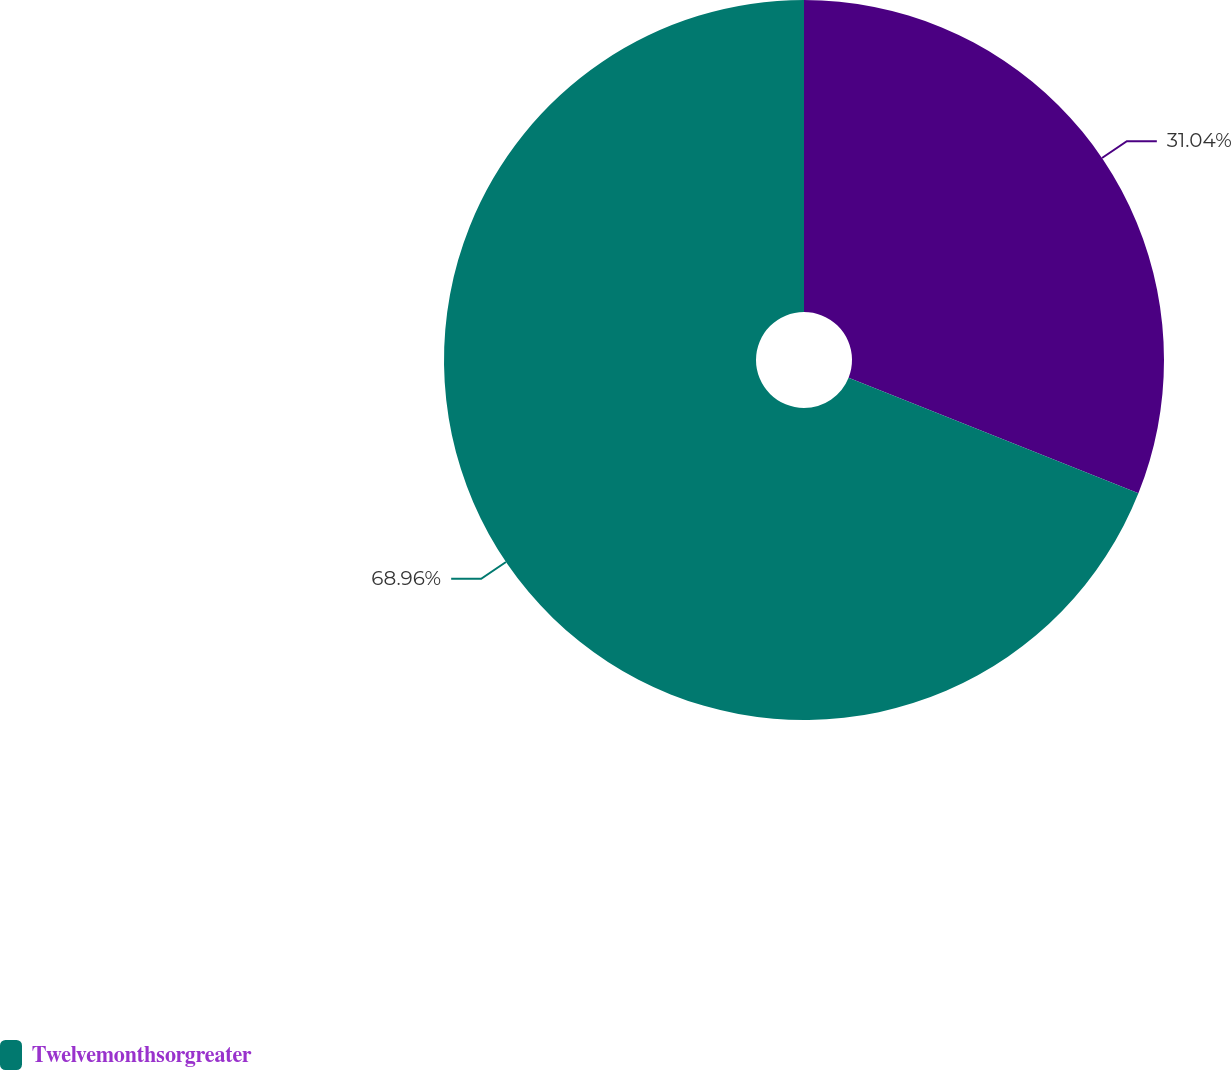Convert chart. <chart><loc_0><loc_0><loc_500><loc_500><pie_chart><ecel><fcel>Twelvemonthsorgreater<nl><fcel>31.04%<fcel>68.96%<nl></chart> 